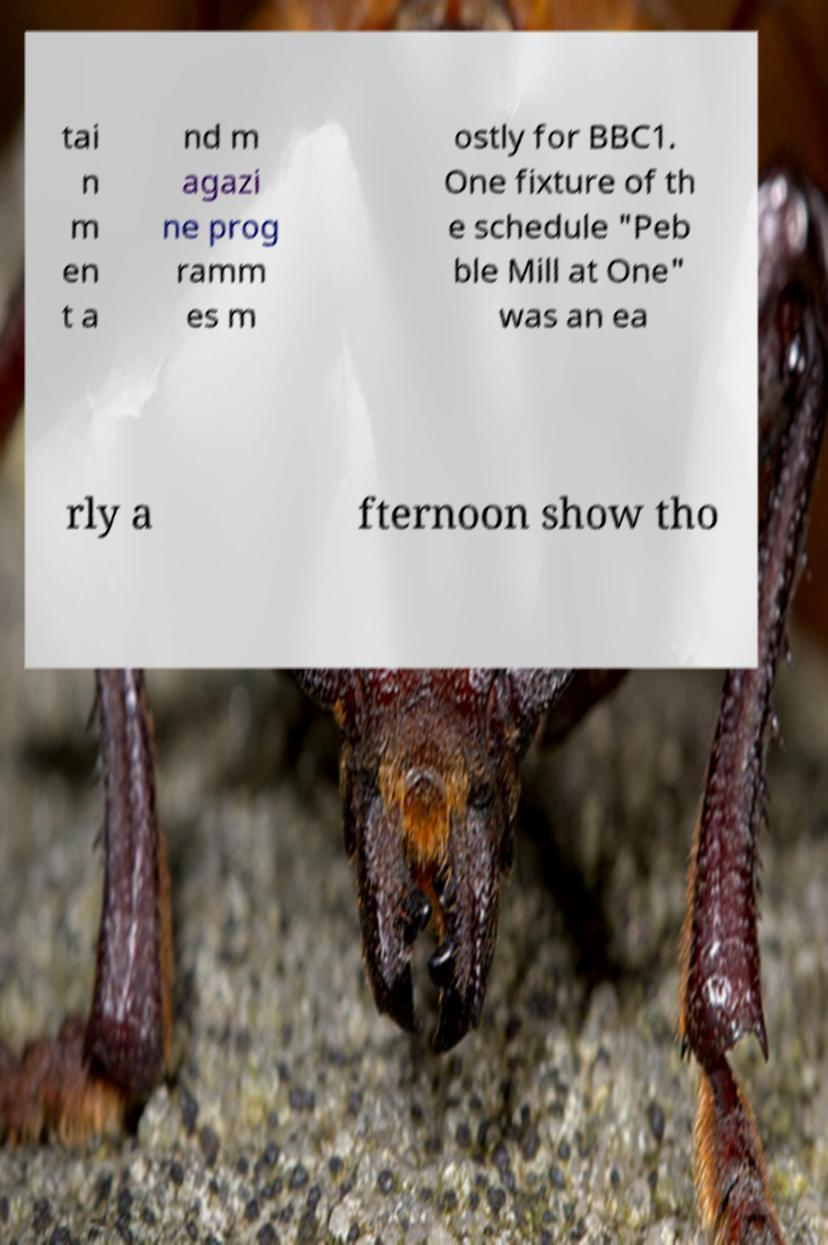Could you extract and type out the text from this image? tai n m en t a nd m agazi ne prog ramm es m ostly for BBC1. One fixture of th e schedule "Peb ble Mill at One" was an ea rly a fternoon show tho 